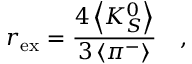<formula> <loc_0><loc_0><loc_500><loc_500>r _ { e x } = \frac { 4 \left < K _ { S } ^ { 0 } \right > } { 3 \left < \pi ^ { - } \right > } \quad ,</formula> 